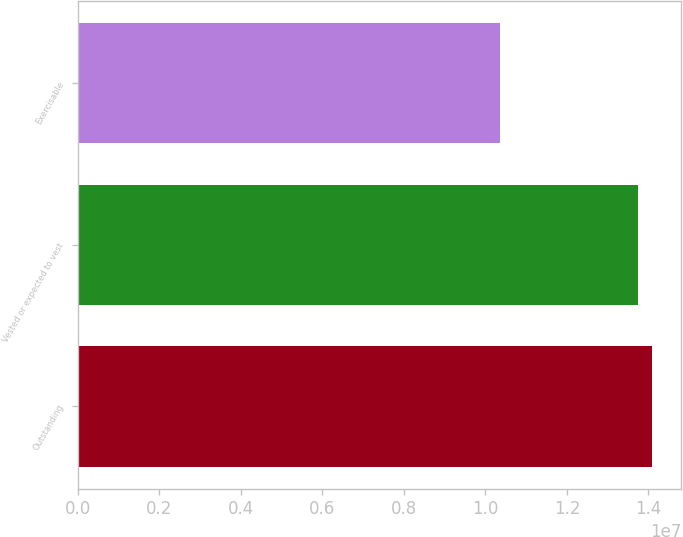Convert chart. <chart><loc_0><loc_0><loc_500><loc_500><bar_chart><fcel>Outstanding<fcel>Vested or expected to vest<fcel>Exercisable<nl><fcel>1.40975e+07<fcel>1.37533e+07<fcel>1.03575e+07<nl></chart> 